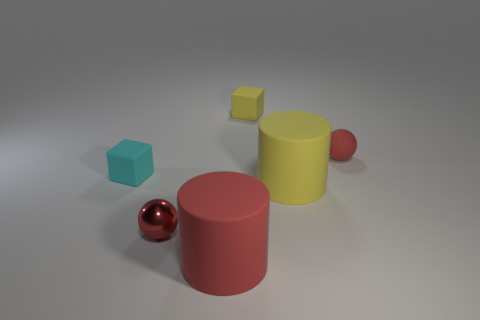Add 1 red matte objects. How many objects exist? 7 Subtract all blocks. How many objects are left? 4 Subtract all red rubber spheres. Subtract all rubber blocks. How many objects are left? 3 Add 5 large yellow cylinders. How many large yellow cylinders are left? 6 Add 1 red metallic things. How many red metallic things exist? 2 Subtract all yellow blocks. How many blocks are left? 1 Subtract 0 brown blocks. How many objects are left? 6 Subtract 2 blocks. How many blocks are left? 0 Subtract all red cylinders. Subtract all cyan spheres. How many cylinders are left? 1 Subtract all green cylinders. How many cyan spheres are left? 0 